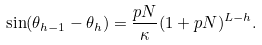Convert formula to latex. <formula><loc_0><loc_0><loc_500><loc_500>\sin ( \theta _ { h - 1 } - \theta _ { h } ) = \frac { p N } { \kappa } ( 1 + p N ) ^ { L - h } .</formula> 